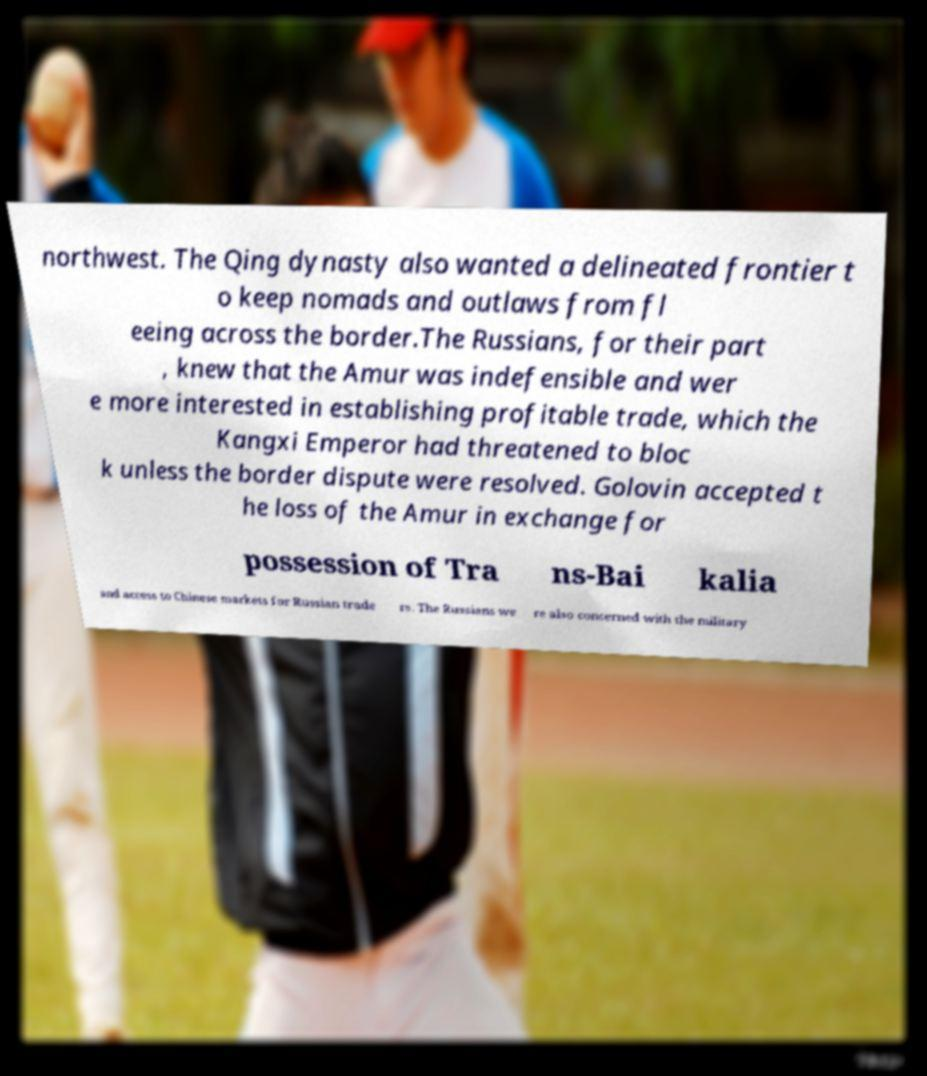Can you accurately transcribe the text from the provided image for me? northwest. The Qing dynasty also wanted a delineated frontier t o keep nomads and outlaws from fl eeing across the border.The Russians, for their part , knew that the Amur was indefensible and wer e more interested in establishing profitable trade, which the Kangxi Emperor had threatened to bloc k unless the border dispute were resolved. Golovin accepted t he loss of the Amur in exchange for possession of Tra ns-Bai kalia and access to Chinese markets for Russian trade rs. The Russians we re also concerned with the military 